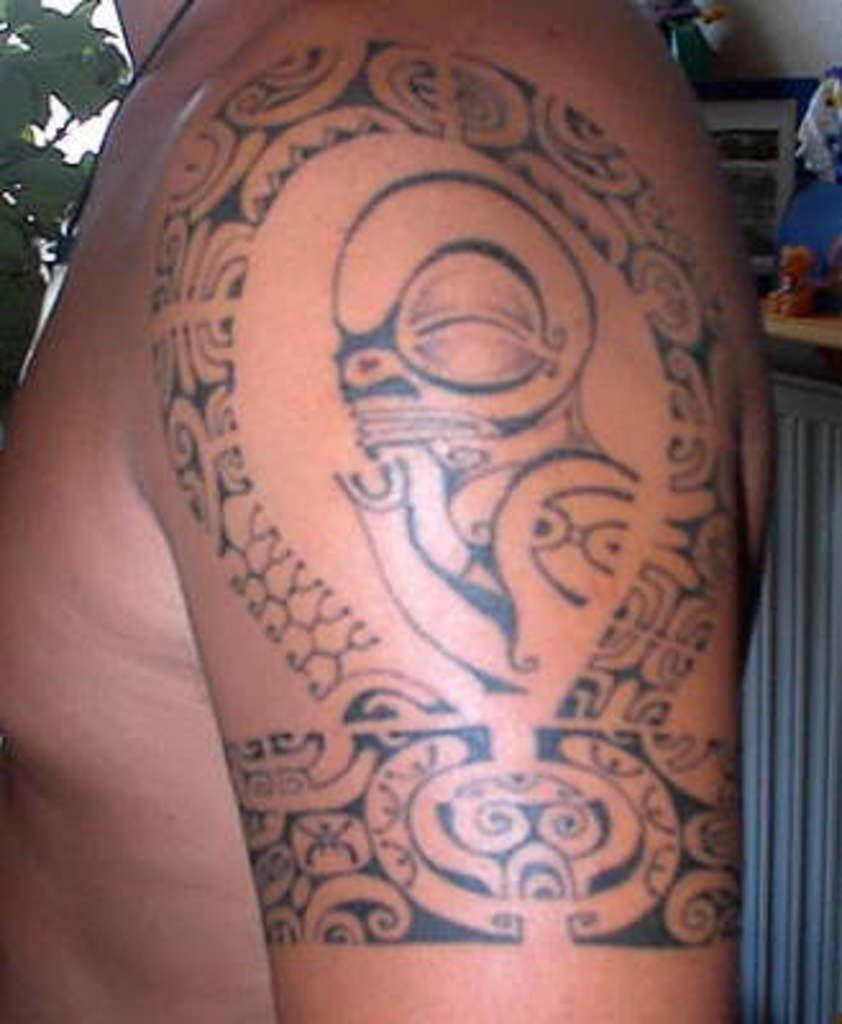What can be seen on the person's hand in the image? There is a tattoo on a person's hand in the image. What type of natural elements can be seen in the background of the image? There are leaves visible in the background of the image. What else can be seen in the background of the image besides leaves? There are some objects in the background of the image. What type of clover is being cooked in the oven in the image? There is no clover or oven present in the image. 